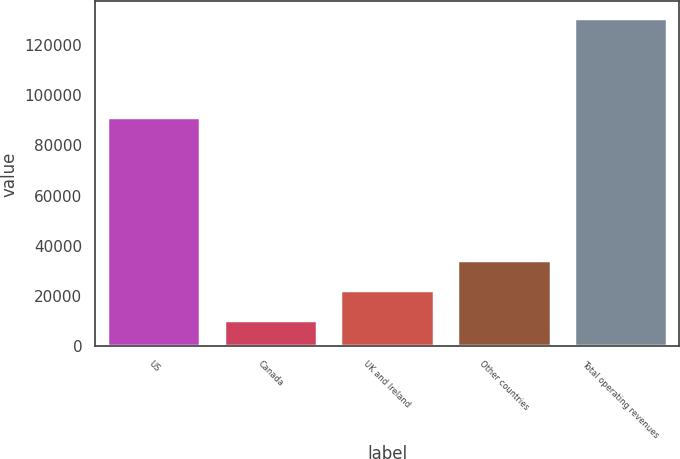Convert chart. <chart><loc_0><loc_0><loc_500><loc_500><bar_chart><fcel>US<fcel>Canada<fcel>UK and Ireland<fcel>Other countries<fcel>Total operating revenues<nl><fcel>91499<fcel>10410<fcel>22453.4<fcel>34496.8<fcel>130844<nl></chart> 